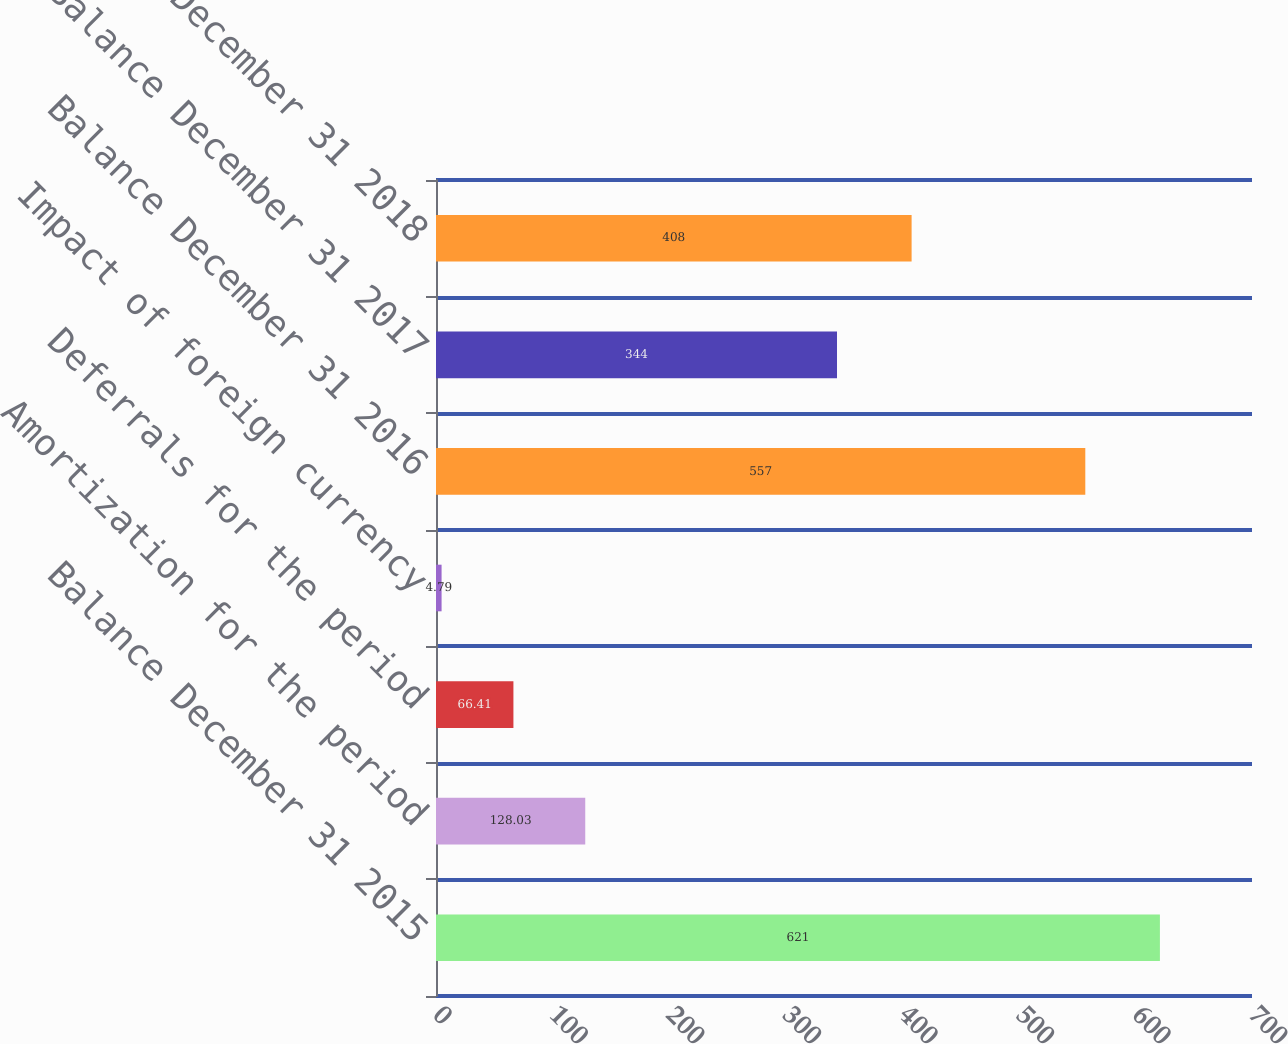Convert chart to OTSL. <chart><loc_0><loc_0><loc_500><loc_500><bar_chart><fcel>Balance December 31 2015<fcel>Amortization for the period<fcel>Deferrals for the period<fcel>Impact of foreign currency<fcel>Balance December 31 2016<fcel>Balance December 31 2017<fcel>Balance December 31 2018<nl><fcel>621<fcel>128.03<fcel>66.41<fcel>4.79<fcel>557<fcel>344<fcel>408<nl></chart> 